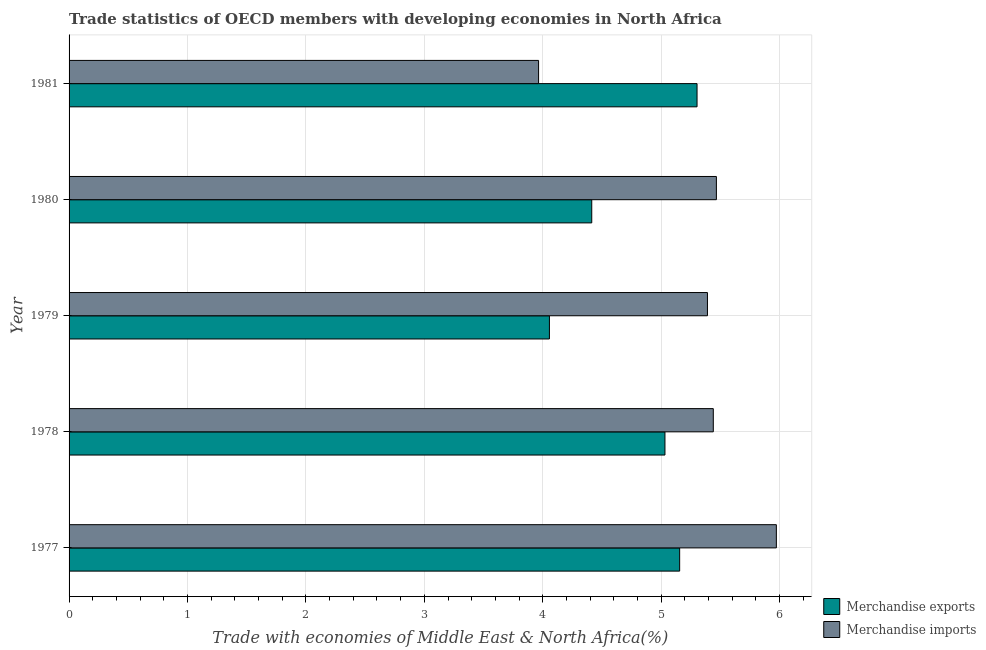How many bars are there on the 2nd tick from the top?
Make the answer very short. 2. How many bars are there on the 1st tick from the bottom?
Ensure brevity in your answer.  2. What is the label of the 4th group of bars from the top?
Give a very brief answer. 1978. What is the merchandise exports in 1977?
Your response must be concise. 5.16. Across all years, what is the maximum merchandise exports?
Your answer should be very brief. 5.3. Across all years, what is the minimum merchandise exports?
Provide a succinct answer. 4.06. In which year was the merchandise exports minimum?
Offer a terse response. 1979. What is the total merchandise exports in the graph?
Your answer should be very brief. 23.96. What is the difference between the merchandise exports in 1977 and that in 1978?
Provide a succinct answer. 0.12. What is the difference between the merchandise exports in 1977 and the merchandise imports in 1978?
Offer a very short reply. -0.28. What is the average merchandise exports per year?
Offer a terse response. 4.79. In the year 1977, what is the difference between the merchandise exports and merchandise imports?
Your response must be concise. -0.82. In how many years, is the merchandise imports greater than 5.2 %?
Provide a succinct answer. 4. What is the ratio of the merchandise exports in 1978 to that in 1979?
Offer a terse response. 1.24. Is the difference between the merchandise exports in 1980 and 1981 greater than the difference between the merchandise imports in 1980 and 1981?
Keep it short and to the point. No. What is the difference between the highest and the second highest merchandise exports?
Make the answer very short. 0.15. What is the difference between the highest and the lowest merchandise exports?
Provide a succinct answer. 1.25. In how many years, is the merchandise exports greater than the average merchandise exports taken over all years?
Your response must be concise. 3. How many bars are there?
Provide a short and direct response. 10. Are all the bars in the graph horizontal?
Offer a very short reply. Yes. What is the difference between two consecutive major ticks on the X-axis?
Your response must be concise. 1. Does the graph contain any zero values?
Make the answer very short. No. Does the graph contain grids?
Your answer should be very brief. Yes. What is the title of the graph?
Provide a short and direct response. Trade statistics of OECD members with developing economies in North Africa. Does "UN agencies" appear as one of the legend labels in the graph?
Keep it short and to the point. No. What is the label or title of the X-axis?
Offer a terse response. Trade with economies of Middle East & North Africa(%). What is the Trade with economies of Middle East & North Africa(%) in Merchandise exports in 1977?
Offer a terse response. 5.16. What is the Trade with economies of Middle East & North Africa(%) of Merchandise imports in 1977?
Ensure brevity in your answer.  5.97. What is the Trade with economies of Middle East & North Africa(%) of Merchandise exports in 1978?
Provide a succinct answer. 5.03. What is the Trade with economies of Middle East & North Africa(%) in Merchandise imports in 1978?
Keep it short and to the point. 5.44. What is the Trade with economies of Middle East & North Africa(%) in Merchandise exports in 1979?
Give a very brief answer. 4.06. What is the Trade with economies of Middle East & North Africa(%) in Merchandise imports in 1979?
Provide a succinct answer. 5.39. What is the Trade with economies of Middle East & North Africa(%) in Merchandise exports in 1980?
Your answer should be compact. 4.41. What is the Trade with economies of Middle East & North Africa(%) in Merchandise imports in 1980?
Keep it short and to the point. 5.47. What is the Trade with economies of Middle East & North Africa(%) in Merchandise exports in 1981?
Ensure brevity in your answer.  5.3. What is the Trade with economies of Middle East & North Africa(%) of Merchandise imports in 1981?
Your answer should be very brief. 3.96. Across all years, what is the maximum Trade with economies of Middle East & North Africa(%) in Merchandise exports?
Keep it short and to the point. 5.3. Across all years, what is the maximum Trade with economies of Middle East & North Africa(%) in Merchandise imports?
Ensure brevity in your answer.  5.97. Across all years, what is the minimum Trade with economies of Middle East & North Africa(%) of Merchandise exports?
Offer a very short reply. 4.06. Across all years, what is the minimum Trade with economies of Middle East & North Africa(%) of Merchandise imports?
Provide a succinct answer. 3.96. What is the total Trade with economies of Middle East & North Africa(%) of Merchandise exports in the graph?
Make the answer very short. 23.96. What is the total Trade with economies of Middle East & North Africa(%) of Merchandise imports in the graph?
Ensure brevity in your answer.  26.23. What is the difference between the Trade with economies of Middle East & North Africa(%) of Merchandise exports in 1977 and that in 1978?
Your answer should be compact. 0.12. What is the difference between the Trade with economies of Middle East & North Africa(%) in Merchandise imports in 1977 and that in 1978?
Keep it short and to the point. 0.53. What is the difference between the Trade with economies of Middle East & North Africa(%) in Merchandise exports in 1977 and that in 1979?
Give a very brief answer. 1.1. What is the difference between the Trade with economies of Middle East & North Africa(%) of Merchandise imports in 1977 and that in 1979?
Offer a terse response. 0.58. What is the difference between the Trade with economies of Middle East & North Africa(%) in Merchandise exports in 1977 and that in 1980?
Offer a very short reply. 0.74. What is the difference between the Trade with economies of Middle East & North Africa(%) in Merchandise imports in 1977 and that in 1980?
Give a very brief answer. 0.51. What is the difference between the Trade with economies of Middle East & North Africa(%) in Merchandise exports in 1977 and that in 1981?
Offer a very short reply. -0.15. What is the difference between the Trade with economies of Middle East & North Africa(%) of Merchandise imports in 1977 and that in 1981?
Offer a very short reply. 2.01. What is the difference between the Trade with economies of Middle East & North Africa(%) of Merchandise exports in 1978 and that in 1979?
Offer a very short reply. 0.98. What is the difference between the Trade with economies of Middle East & North Africa(%) of Merchandise imports in 1978 and that in 1979?
Provide a short and direct response. 0.05. What is the difference between the Trade with economies of Middle East & North Africa(%) of Merchandise exports in 1978 and that in 1980?
Keep it short and to the point. 0.62. What is the difference between the Trade with economies of Middle East & North Africa(%) of Merchandise imports in 1978 and that in 1980?
Make the answer very short. -0.03. What is the difference between the Trade with economies of Middle East & North Africa(%) in Merchandise exports in 1978 and that in 1981?
Your answer should be very brief. -0.27. What is the difference between the Trade with economies of Middle East & North Africa(%) in Merchandise imports in 1978 and that in 1981?
Ensure brevity in your answer.  1.48. What is the difference between the Trade with economies of Middle East & North Africa(%) of Merchandise exports in 1979 and that in 1980?
Offer a terse response. -0.36. What is the difference between the Trade with economies of Middle East & North Africa(%) in Merchandise imports in 1979 and that in 1980?
Ensure brevity in your answer.  -0.08. What is the difference between the Trade with economies of Middle East & North Africa(%) of Merchandise exports in 1979 and that in 1981?
Offer a very short reply. -1.25. What is the difference between the Trade with economies of Middle East & North Africa(%) in Merchandise imports in 1979 and that in 1981?
Offer a terse response. 1.43. What is the difference between the Trade with economies of Middle East & North Africa(%) of Merchandise exports in 1980 and that in 1981?
Your answer should be very brief. -0.89. What is the difference between the Trade with economies of Middle East & North Africa(%) in Merchandise imports in 1980 and that in 1981?
Provide a succinct answer. 1.5. What is the difference between the Trade with economies of Middle East & North Africa(%) in Merchandise exports in 1977 and the Trade with economies of Middle East & North Africa(%) in Merchandise imports in 1978?
Your answer should be very brief. -0.28. What is the difference between the Trade with economies of Middle East & North Africa(%) in Merchandise exports in 1977 and the Trade with economies of Middle East & North Africa(%) in Merchandise imports in 1979?
Keep it short and to the point. -0.23. What is the difference between the Trade with economies of Middle East & North Africa(%) of Merchandise exports in 1977 and the Trade with economies of Middle East & North Africa(%) of Merchandise imports in 1980?
Offer a terse response. -0.31. What is the difference between the Trade with economies of Middle East & North Africa(%) of Merchandise exports in 1977 and the Trade with economies of Middle East & North Africa(%) of Merchandise imports in 1981?
Provide a succinct answer. 1.19. What is the difference between the Trade with economies of Middle East & North Africa(%) of Merchandise exports in 1978 and the Trade with economies of Middle East & North Africa(%) of Merchandise imports in 1979?
Your answer should be very brief. -0.36. What is the difference between the Trade with economies of Middle East & North Africa(%) of Merchandise exports in 1978 and the Trade with economies of Middle East & North Africa(%) of Merchandise imports in 1980?
Provide a short and direct response. -0.43. What is the difference between the Trade with economies of Middle East & North Africa(%) in Merchandise exports in 1978 and the Trade with economies of Middle East & North Africa(%) in Merchandise imports in 1981?
Offer a terse response. 1.07. What is the difference between the Trade with economies of Middle East & North Africa(%) of Merchandise exports in 1979 and the Trade with economies of Middle East & North Africa(%) of Merchandise imports in 1980?
Provide a short and direct response. -1.41. What is the difference between the Trade with economies of Middle East & North Africa(%) of Merchandise exports in 1979 and the Trade with economies of Middle East & North Africa(%) of Merchandise imports in 1981?
Offer a terse response. 0.09. What is the difference between the Trade with economies of Middle East & North Africa(%) of Merchandise exports in 1980 and the Trade with economies of Middle East & North Africa(%) of Merchandise imports in 1981?
Offer a very short reply. 0.45. What is the average Trade with economies of Middle East & North Africa(%) in Merchandise exports per year?
Offer a terse response. 4.79. What is the average Trade with economies of Middle East & North Africa(%) in Merchandise imports per year?
Offer a terse response. 5.25. In the year 1977, what is the difference between the Trade with economies of Middle East & North Africa(%) of Merchandise exports and Trade with economies of Middle East & North Africa(%) of Merchandise imports?
Ensure brevity in your answer.  -0.82. In the year 1978, what is the difference between the Trade with economies of Middle East & North Africa(%) in Merchandise exports and Trade with economies of Middle East & North Africa(%) in Merchandise imports?
Your response must be concise. -0.41. In the year 1979, what is the difference between the Trade with economies of Middle East & North Africa(%) of Merchandise exports and Trade with economies of Middle East & North Africa(%) of Merchandise imports?
Your answer should be compact. -1.33. In the year 1980, what is the difference between the Trade with economies of Middle East & North Africa(%) in Merchandise exports and Trade with economies of Middle East & North Africa(%) in Merchandise imports?
Your response must be concise. -1.05. In the year 1981, what is the difference between the Trade with economies of Middle East & North Africa(%) of Merchandise exports and Trade with economies of Middle East & North Africa(%) of Merchandise imports?
Your response must be concise. 1.34. What is the ratio of the Trade with economies of Middle East & North Africa(%) of Merchandise exports in 1977 to that in 1978?
Provide a succinct answer. 1.02. What is the ratio of the Trade with economies of Middle East & North Africa(%) in Merchandise imports in 1977 to that in 1978?
Your answer should be compact. 1.1. What is the ratio of the Trade with economies of Middle East & North Africa(%) in Merchandise exports in 1977 to that in 1979?
Provide a short and direct response. 1.27. What is the ratio of the Trade with economies of Middle East & North Africa(%) of Merchandise imports in 1977 to that in 1979?
Offer a very short reply. 1.11. What is the ratio of the Trade with economies of Middle East & North Africa(%) in Merchandise exports in 1977 to that in 1980?
Provide a succinct answer. 1.17. What is the ratio of the Trade with economies of Middle East & North Africa(%) in Merchandise imports in 1977 to that in 1980?
Provide a short and direct response. 1.09. What is the ratio of the Trade with economies of Middle East & North Africa(%) of Merchandise exports in 1977 to that in 1981?
Your response must be concise. 0.97. What is the ratio of the Trade with economies of Middle East & North Africa(%) of Merchandise imports in 1977 to that in 1981?
Give a very brief answer. 1.51. What is the ratio of the Trade with economies of Middle East & North Africa(%) of Merchandise exports in 1978 to that in 1979?
Give a very brief answer. 1.24. What is the ratio of the Trade with economies of Middle East & North Africa(%) in Merchandise imports in 1978 to that in 1979?
Provide a succinct answer. 1.01. What is the ratio of the Trade with economies of Middle East & North Africa(%) of Merchandise exports in 1978 to that in 1980?
Offer a terse response. 1.14. What is the ratio of the Trade with economies of Middle East & North Africa(%) of Merchandise imports in 1978 to that in 1980?
Ensure brevity in your answer.  1. What is the ratio of the Trade with economies of Middle East & North Africa(%) of Merchandise exports in 1978 to that in 1981?
Keep it short and to the point. 0.95. What is the ratio of the Trade with economies of Middle East & North Africa(%) of Merchandise imports in 1978 to that in 1981?
Offer a terse response. 1.37. What is the ratio of the Trade with economies of Middle East & North Africa(%) of Merchandise exports in 1979 to that in 1980?
Provide a succinct answer. 0.92. What is the ratio of the Trade with economies of Middle East & North Africa(%) in Merchandise imports in 1979 to that in 1980?
Your answer should be very brief. 0.99. What is the ratio of the Trade with economies of Middle East & North Africa(%) in Merchandise exports in 1979 to that in 1981?
Your answer should be very brief. 0.76. What is the ratio of the Trade with economies of Middle East & North Africa(%) of Merchandise imports in 1979 to that in 1981?
Offer a terse response. 1.36. What is the ratio of the Trade with economies of Middle East & North Africa(%) in Merchandise exports in 1980 to that in 1981?
Your answer should be compact. 0.83. What is the ratio of the Trade with economies of Middle East & North Africa(%) in Merchandise imports in 1980 to that in 1981?
Provide a short and direct response. 1.38. What is the difference between the highest and the second highest Trade with economies of Middle East & North Africa(%) in Merchandise exports?
Give a very brief answer. 0.15. What is the difference between the highest and the second highest Trade with economies of Middle East & North Africa(%) in Merchandise imports?
Make the answer very short. 0.51. What is the difference between the highest and the lowest Trade with economies of Middle East & North Africa(%) in Merchandise exports?
Provide a succinct answer. 1.25. What is the difference between the highest and the lowest Trade with economies of Middle East & North Africa(%) in Merchandise imports?
Give a very brief answer. 2.01. 